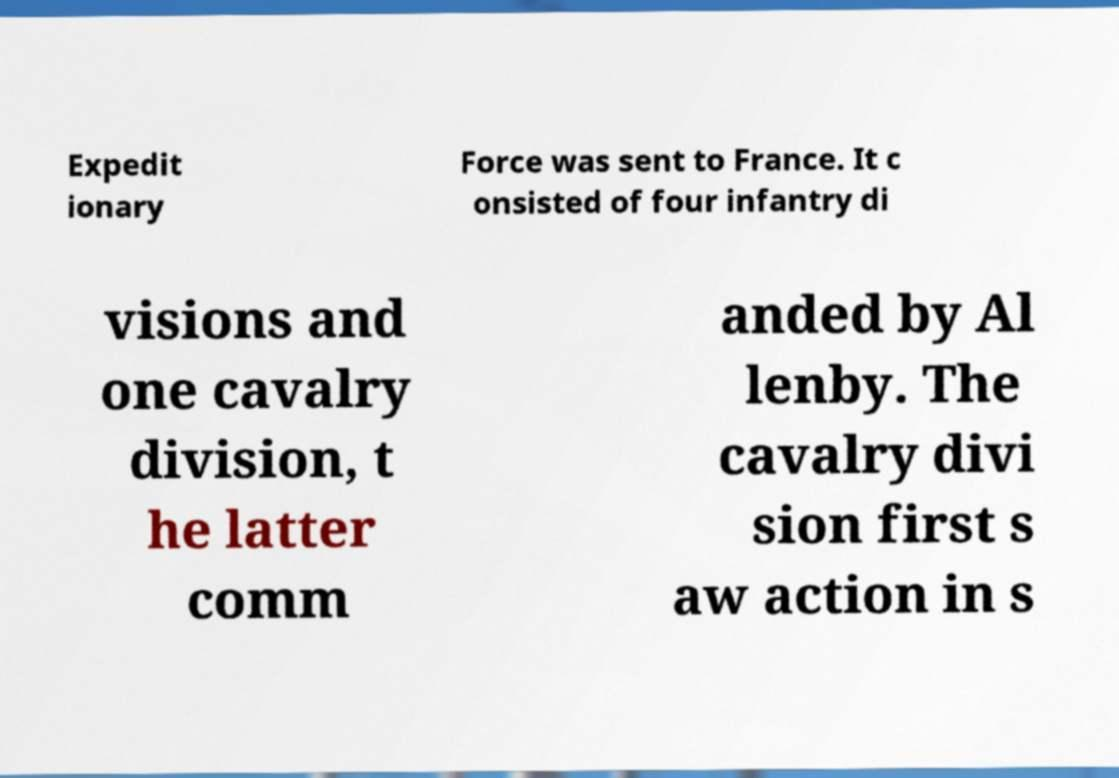Can you read and provide the text displayed in the image?This photo seems to have some interesting text. Can you extract and type it out for me? Expedit ionary Force was sent to France. It c onsisted of four infantry di visions and one cavalry division, t he latter comm anded by Al lenby. The cavalry divi sion first s aw action in s 